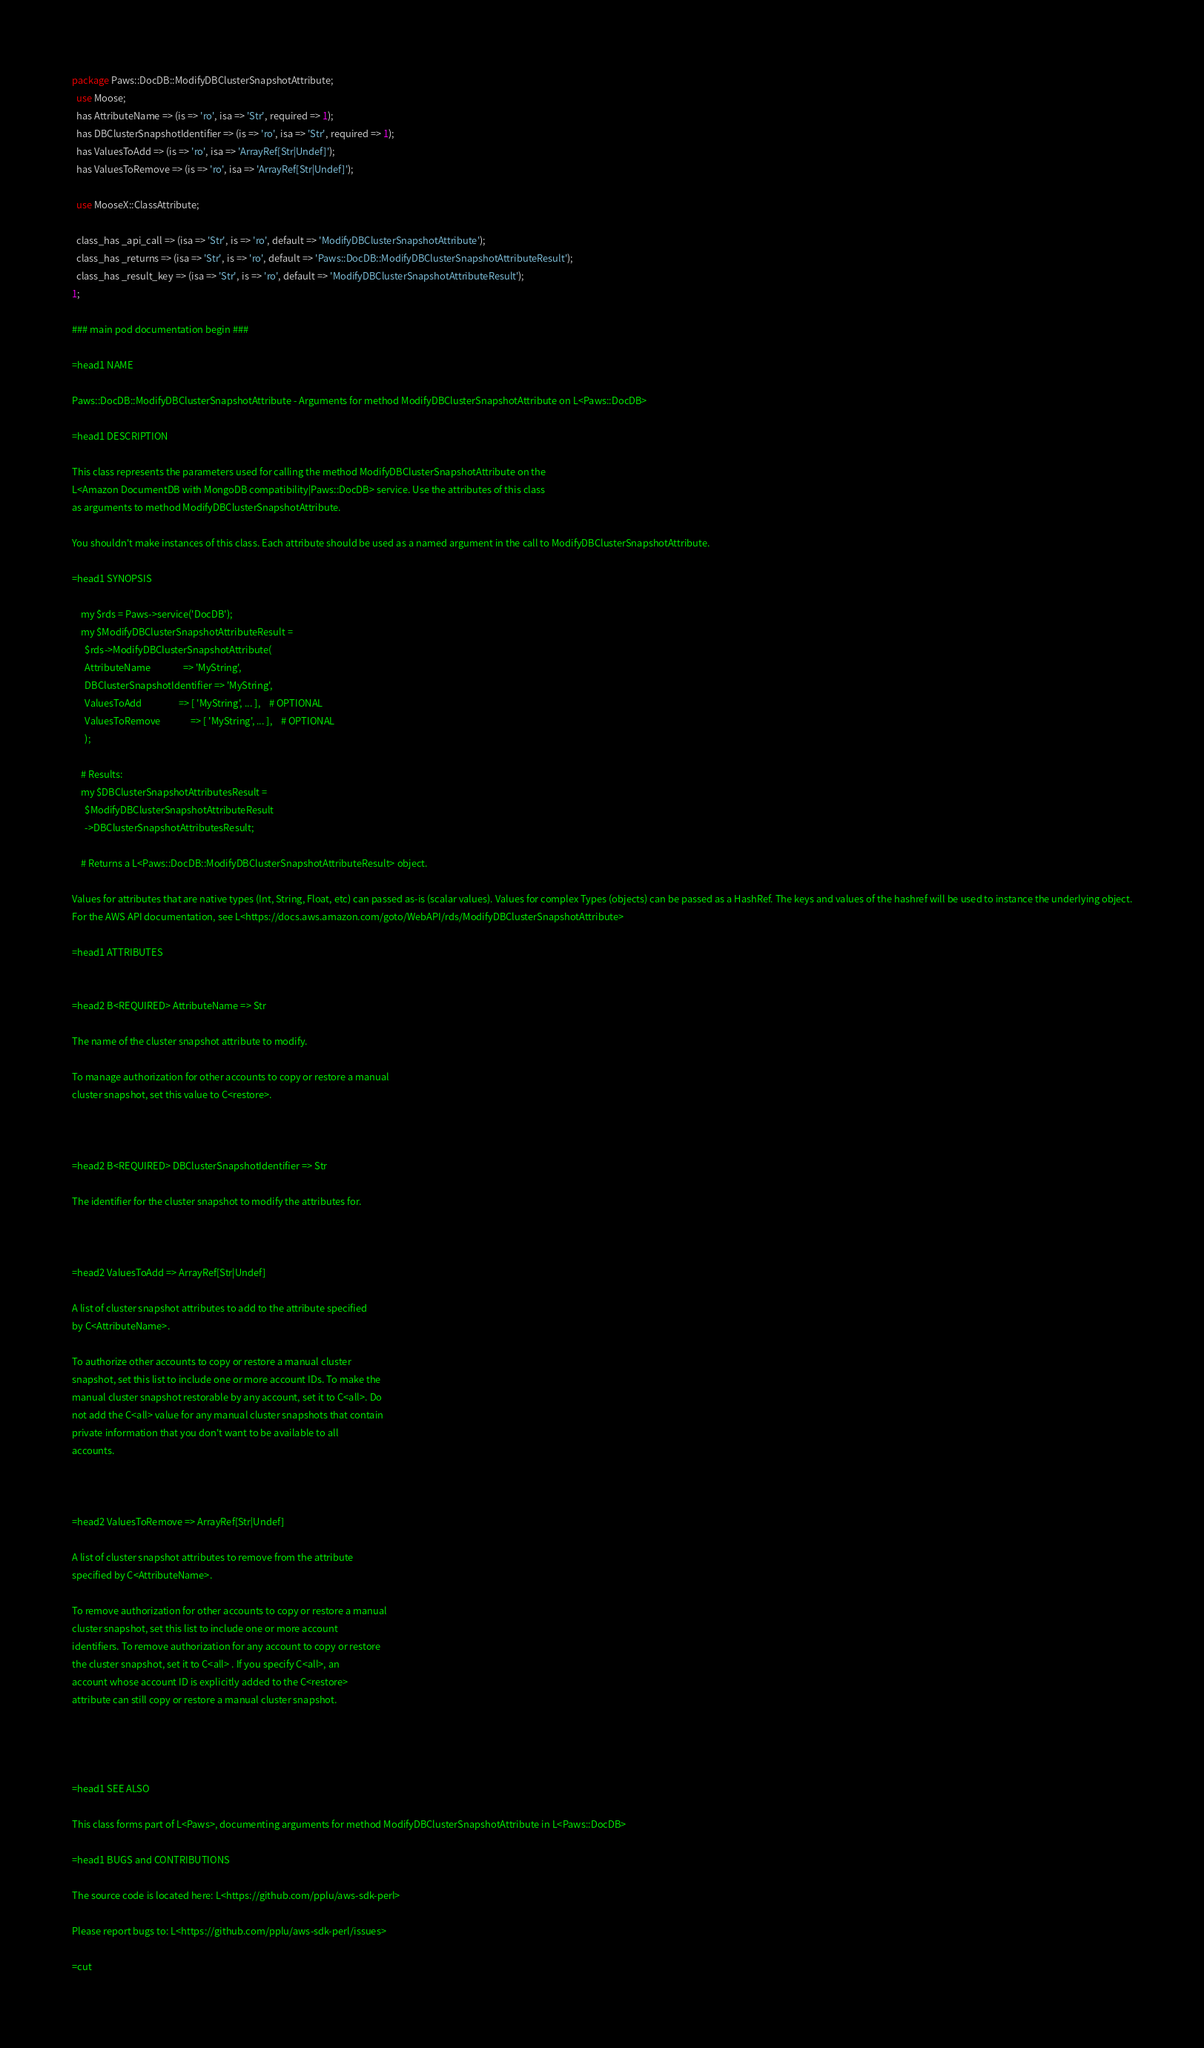Convert code to text. <code><loc_0><loc_0><loc_500><loc_500><_Perl_>
package Paws::DocDB::ModifyDBClusterSnapshotAttribute;
  use Moose;
  has AttributeName => (is => 'ro', isa => 'Str', required => 1);
  has DBClusterSnapshotIdentifier => (is => 'ro', isa => 'Str', required => 1);
  has ValuesToAdd => (is => 'ro', isa => 'ArrayRef[Str|Undef]');
  has ValuesToRemove => (is => 'ro', isa => 'ArrayRef[Str|Undef]');

  use MooseX::ClassAttribute;

  class_has _api_call => (isa => 'Str', is => 'ro', default => 'ModifyDBClusterSnapshotAttribute');
  class_has _returns => (isa => 'Str', is => 'ro', default => 'Paws::DocDB::ModifyDBClusterSnapshotAttributeResult');
  class_has _result_key => (isa => 'Str', is => 'ro', default => 'ModifyDBClusterSnapshotAttributeResult');
1;

### main pod documentation begin ###

=head1 NAME

Paws::DocDB::ModifyDBClusterSnapshotAttribute - Arguments for method ModifyDBClusterSnapshotAttribute on L<Paws::DocDB>

=head1 DESCRIPTION

This class represents the parameters used for calling the method ModifyDBClusterSnapshotAttribute on the
L<Amazon DocumentDB with MongoDB compatibility|Paws::DocDB> service. Use the attributes of this class
as arguments to method ModifyDBClusterSnapshotAttribute.

You shouldn't make instances of this class. Each attribute should be used as a named argument in the call to ModifyDBClusterSnapshotAttribute.

=head1 SYNOPSIS

    my $rds = Paws->service('DocDB');
    my $ModifyDBClusterSnapshotAttributeResult =
      $rds->ModifyDBClusterSnapshotAttribute(
      AttributeName               => 'MyString',
      DBClusterSnapshotIdentifier => 'MyString',
      ValuesToAdd                 => [ 'MyString', ... ],    # OPTIONAL
      ValuesToRemove              => [ 'MyString', ... ],    # OPTIONAL
      );

    # Results:
    my $DBClusterSnapshotAttributesResult =
      $ModifyDBClusterSnapshotAttributeResult
      ->DBClusterSnapshotAttributesResult;

    # Returns a L<Paws::DocDB::ModifyDBClusterSnapshotAttributeResult> object.

Values for attributes that are native types (Int, String, Float, etc) can passed as-is (scalar values). Values for complex Types (objects) can be passed as a HashRef. The keys and values of the hashref will be used to instance the underlying object.
For the AWS API documentation, see L<https://docs.aws.amazon.com/goto/WebAPI/rds/ModifyDBClusterSnapshotAttribute>

=head1 ATTRIBUTES


=head2 B<REQUIRED> AttributeName => Str

The name of the cluster snapshot attribute to modify.

To manage authorization for other accounts to copy or restore a manual
cluster snapshot, set this value to C<restore>.



=head2 B<REQUIRED> DBClusterSnapshotIdentifier => Str

The identifier for the cluster snapshot to modify the attributes for.



=head2 ValuesToAdd => ArrayRef[Str|Undef]

A list of cluster snapshot attributes to add to the attribute specified
by C<AttributeName>.

To authorize other accounts to copy or restore a manual cluster
snapshot, set this list to include one or more account IDs. To make the
manual cluster snapshot restorable by any account, set it to C<all>. Do
not add the C<all> value for any manual cluster snapshots that contain
private information that you don't want to be available to all
accounts.



=head2 ValuesToRemove => ArrayRef[Str|Undef]

A list of cluster snapshot attributes to remove from the attribute
specified by C<AttributeName>.

To remove authorization for other accounts to copy or restore a manual
cluster snapshot, set this list to include one or more account
identifiers. To remove authorization for any account to copy or restore
the cluster snapshot, set it to C<all> . If you specify C<all>, an
account whose account ID is explicitly added to the C<restore>
attribute can still copy or restore a manual cluster snapshot.




=head1 SEE ALSO

This class forms part of L<Paws>, documenting arguments for method ModifyDBClusterSnapshotAttribute in L<Paws::DocDB>

=head1 BUGS and CONTRIBUTIONS

The source code is located here: L<https://github.com/pplu/aws-sdk-perl>

Please report bugs to: L<https://github.com/pplu/aws-sdk-perl/issues>

=cut

</code> 